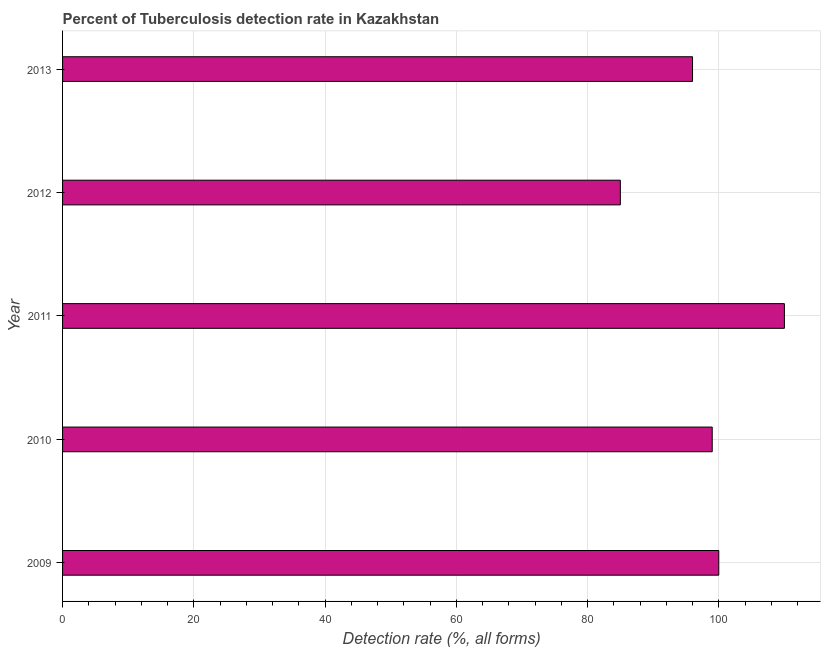Does the graph contain any zero values?
Your answer should be compact. No. What is the title of the graph?
Your answer should be compact. Percent of Tuberculosis detection rate in Kazakhstan. What is the label or title of the X-axis?
Offer a very short reply. Detection rate (%, all forms). What is the label or title of the Y-axis?
Your answer should be very brief. Year. What is the detection rate of tuberculosis in 2011?
Offer a very short reply. 110. Across all years, what is the maximum detection rate of tuberculosis?
Keep it short and to the point. 110. Across all years, what is the minimum detection rate of tuberculosis?
Give a very brief answer. 85. In which year was the detection rate of tuberculosis maximum?
Give a very brief answer. 2011. What is the sum of the detection rate of tuberculosis?
Keep it short and to the point. 490. What is the difference between the detection rate of tuberculosis in 2011 and 2012?
Make the answer very short. 25. What is the average detection rate of tuberculosis per year?
Your answer should be compact. 98. In how many years, is the detection rate of tuberculosis greater than 88 %?
Provide a succinct answer. 4. What is the ratio of the detection rate of tuberculosis in 2009 to that in 2011?
Ensure brevity in your answer.  0.91. Are all the bars in the graph horizontal?
Provide a short and direct response. Yes. How many years are there in the graph?
Offer a very short reply. 5. Are the values on the major ticks of X-axis written in scientific E-notation?
Offer a very short reply. No. What is the Detection rate (%, all forms) in 2009?
Keep it short and to the point. 100. What is the Detection rate (%, all forms) in 2011?
Offer a very short reply. 110. What is the Detection rate (%, all forms) of 2012?
Your answer should be compact. 85. What is the Detection rate (%, all forms) of 2013?
Provide a short and direct response. 96. What is the difference between the Detection rate (%, all forms) in 2009 and 2010?
Offer a terse response. 1. What is the difference between the Detection rate (%, all forms) in 2009 and 2013?
Provide a succinct answer. 4. What is the difference between the Detection rate (%, all forms) in 2010 and 2011?
Ensure brevity in your answer.  -11. What is the difference between the Detection rate (%, all forms) in 2010 and 2012?
Provide a short and direct response. 14. What is the difference between the Detection rate (%, all forms) in 2010 and 2013?
Your answer should be very brief. 3. What is the difference between the Detection rate (%, all forms) in 2011 and 2013?
Give a very brief answer. 14. What is the difference between the Detection rate (%, all forms) in 2012 and 2013?
Make the answer very short. -11. What is the ratio of the Detection rate (%, all forms) in 2009 to that in 2011?
Keep it short and to the point. 0.91. What is the ratio of the Detection rate (%, all forms) in 2009 to that in 2012?
Offer a terse response. 1.18. What is the ratio of the Detection rate (%, all forms) in 2009 to that in 2013?
Make the answer very short. 1.04. What is the ratio of the Detection rate (%, all forms) in 2010 to that in 2011?
Your response must be concise. 0.9. What is the ratio of the Detection rate (%, all forms) in 2010 to that in 2012?
Offer a very short reply. 1.17. What is the ratio of the Detection rate (%, all forms) in 2010 to that in 2013?
Keep it short and to the point. 1.03. What is the ratio of the Detection rate (%, all forms) in 2011 to that in 2012?
Provide a succinct answer. 1.29. What is the ratio of the Detection rate (%, all forms) in 2011 to that in 2013?
Provide a succinct answer. 1.15. What is the ratio of the Detection rate (%, all forms) in 2012 to that in 2013?
Provide a short and direct response. 0.89. 